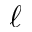<formula> <loc_0><loc_0><loc_500><loc_500>\ell</formula> 